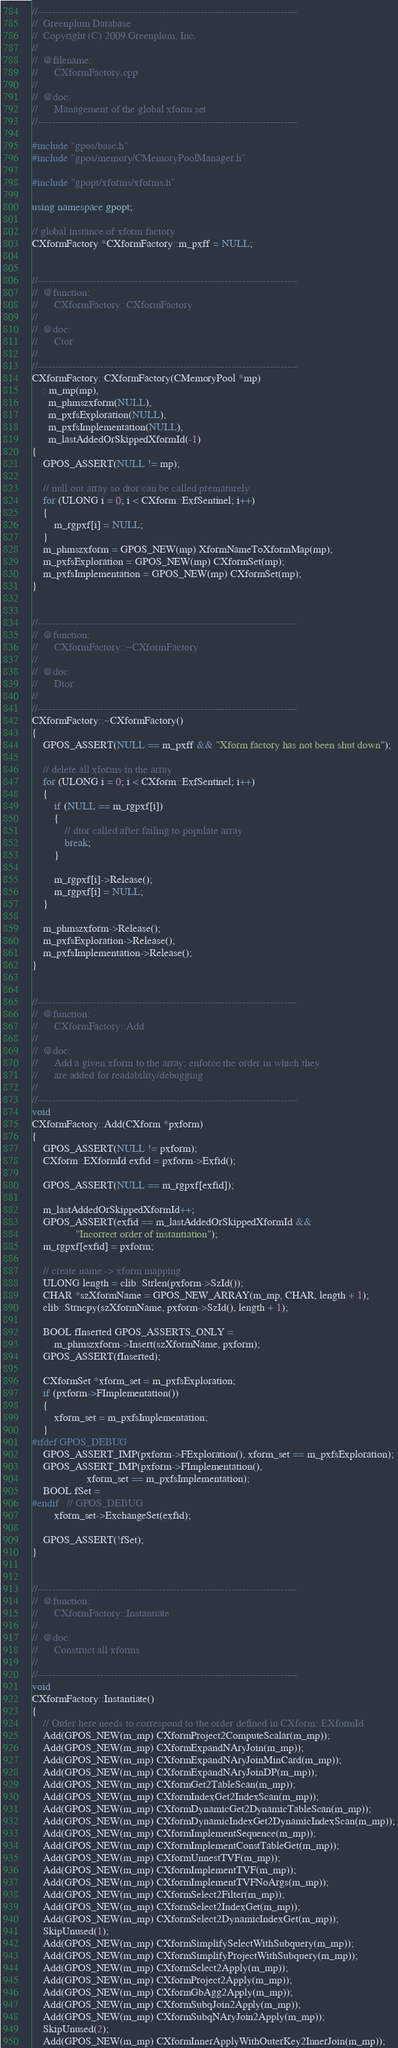Convert code to text. <code><loc_0><loc_0><loc_500><loc_500><_C++_>//---------------------------------------------------------------------------
//	Greenplum Database
//	Copyright (C) 2009 Greenplum, Inc.
//
//	@filename:
//		CXformFactory.cpp
//
//	@doc:
//		Management of the global xform set
//---------------------------------------------------------------------------

#include "gpos/base.h"
#include "gpos/memory/CMemoryPoolManager.h"

#include "gpopt/xforms/xforms.h"

using namespace gpopt;

// global instance of xform factory
CXformFactory *CXformFactory::m_pxff = NULL;


//---------------------------------------------------------------------------
//	@function:
//		CXformFactory::CXformFactory
//
//	@doc:
//		Ctor
//
//---------------------------------------------------------------------------
CXformFactory::CXformFactory(CMemoryPool *mp)
	: m_mp(mp),
	  m_phmszxform(NULL),
	  m_pxfsExploration(NULL),
	  m_pxfsImplementation(NULL),
	  m_lastAddedOrSkippedXformId(-1)
{
	GPOS_ASSERT(NULL != mp);

	// null out array so dtor can be called prematurely
	for (ULONG i = 0; i < CXform::ExfSentinel; i++)
	{
		m_rgpxf[i] = NULL;
	}
	m_phmszxform = GPOS_NEW(mp) XformNameToXformMap(mp);
	m_pxfsExploration = GPOS_NEW(mp) CXformSet(mp);
	m_pxfsImplementation = GPOS_NEW(mp) CXformSet(mp);
}


//---------------------------------------------------------------------------
//	@function:
//		CXformFactory::~CXformFactory
//
//	@doc:
//		Dtor
//
//---------------------------------------------------------------------------
CXformFactory::~CXformFactory()
{
	GPOS_ASSERT(NULL == m_pxff && "Xform factory has not been shut down");

	// delete all xforms in the array
	for (ULONG i = 0; i < CXform::ExfSentinel; i++)
	{
		if (NULL == m_rgpxf[i])
		{
			// dtor called after failing to populate array
			break;
		}

		m_rgpxf[i]->Release();
		m_rgpxf[i] = NULL;
	}

	m_phmszxform->Release();
	m_pxfsExploration->Release();
	m_pxfsImplementation->Release();
}


//---------------------------------------------------------------------------
//	@function:
//		CXformFactory::Add
//
//	@doc:
//		Add a given xform to the array; enforce the order in which they
//		are added for readability/debugging
//
//---------------------------------------------------------------------------
void
CXformFactory::Add(CXform *pxform)
{
	GPOS_ASSERT(NULL != pxform);
	CXform::EXformId exfid = pxform->Exfid();

	GPOS_ASSERT(NULL == m_rgpxf[exfid]);

	m_lastAddedOrSkippedXformId++;
	GPOS_ASSERT(exfid == m_lastAddedOrSkippedXformId &&
				"Incorrect order of instantiation");
	m_rgpxf[exfid] = pxform;

	// create name -> xform mapping
	ULONG length = clib::Strlen(pxform->SzId());
	CHAR *szXformName = GPOS_NEW_ARRAY(m_mp, CHAR, length + 1);
	clib::Strncpy(szXformName, pxform->SzId(), length + 1);

	BOOL fInserted GPOS_ASSERTS_ONLY =
		m_phmszxform->Insert(szXformName, pxform);
	GPOS_ASSERT(fInserted);

	CXformSet *xform_set = m_pxfsExploration;
	if (pxform->FImplementation())
	{
		xform_set = m_pxfsImplementation;
	}
#ifdef GPOS_DEBUG
	GPOS_ASSERT_IMP(pxform->FExploration(), xform_set == m_pxfsExploration);
	GPOS_ASSERT_IMP(pxform->FImplementation(),
					xform_set == m_pxfsImplementation);
	BOOL fSet =
#endif	// GPOS_DEBUG
		xform_set->ExchangeSet(exfid);

	GPOS_ASSERT(!fSet);
}


//---------------------------------------------------------------------------
//	@function:
//		CXformFactory::Instantiate
//
//	@doc:
//		Construct all xforms
//
//---------------------------------------------------------------------------
void
CXformFactory::Instantiate()
{
	// Order here needs to correspond to the order defined in CXform::EXformId
	Add(GPOS_NEW(m_mp) CXformProject2ComputeScalar(m_mp));
	Add(GPOS_NEW(m_mp) CXformExpandNAryJoin(m_mp));
	Add(GPOS_NEW(m_mp) CXformExpandNAryJoinMinCard(m_mp));
	Add(GPOS_NEW(m_mp) CXformExpandNAryJoinDP(m_mp));
	Add(GPOS_NEW(m_mp) CXformGet2TableScan(m_mp));
	Add(GPOS_NEW(m_mp) CXformIndexGet2IndexScan(m_mp));
	Add(GPOS_NEW(m_mp) CXformDynamicGet2DynamicTableScan(m_mp));
	Add(GPOS_NEW(m_mp) CXformDynamicIndexGet2DynamicIndexScan(m_mp));
	Add(GPOS_NEW(m_mp) CXformImplementSequence(m_mp));
	Add(GPOS_NEW(m_mp) CXformImplementConstTableGet(m_mp));
	Add(GPOS_NEW(m_mp) CXformUnnestTVF(m_mp));
	Add(GPOS_NEW(m_mp) CXformImplementTVF(m_mp));
	Add(GPOS_NEW(m_mp) CXformImplementTVFNoArgs(m_mp));
	Add(GPOS_NEW(m_mp) CXformSelect2Filter(m_mp));
	Add(GPOS_NEW(m_mp) CXformSelect2IndexGet(m_mp));
	Add(GPOS_NEW(m_mp) CXformSelect2DynamicIndexGet(m_mp));
	SkipUnused(1);
	Add(GPOS_NEW(m_mp) CXformSimplifySelectWithSubquery(m_mp));
	Add(GPOS_NEW(m_mp) CXformSimplifyProjectWithSubquery(m_mp));
	Add(GPOS_NEW(m_mp) CXformSelect2Apply(m_mp));
	Add(GPOS_NEW(m_mp) CXformProject2Apply(m_mp));
	Add(GPOS_NEW(m_mp) CXformGbAgg2Apply(m_mp));
	Add(GPOS_NEW(m_mp) CXformSubqJoin2Apply(m_mp));
	Add(GPOS_NEW(m_mp) CXformSubqNAryJoin2Apply(m_mp));
	SkipUnused(2);
	Add(GPOS_NEW(m_mp) CXformInnerApplyWithOuterKey2InnerJoin(m_mp));</code> 